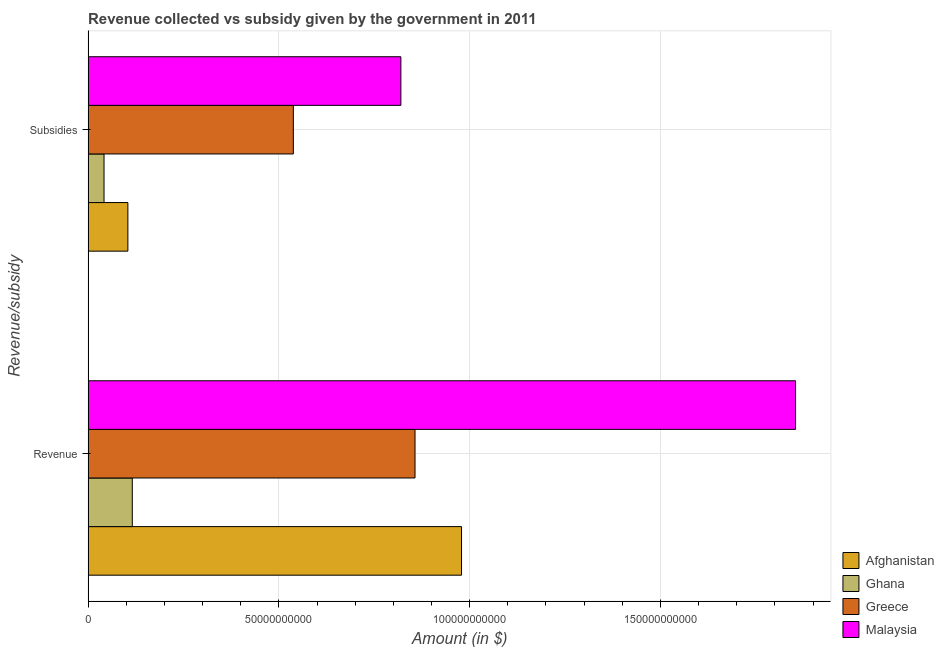Are the number of bars per tick equal to the number of legend labels?
Provide a succinct answer. Yes. What is the label of the 1st group of bars from the top?
Offer a terse response. Subsidies. What is the amount of subsidies given in Ghana?
Ensure brevity in your answer.  4.18e+09. Across all countries, what is the maximum amount of revenue collected?
Provide a short and direct response. 1.85e+11. Across all countries, what is the minimum amount of subsidies given?
Give a very brief answer. 4.18e+09. In which country was the amount of revenue collected maximum?
Offer a terse response. Malaysia. In which country was the amount of revenue collected minimum?
Your response must be concise. Ghana. What is the total amount of subsidies given in the graph?
Make the answer very short. 1.50e+11. What is the difference between the amount of subsidies given in Afghanistan and that in Malaysia?
Your response must be concise. -7.16e+1. What is the difference between the amount of revenue collected in Ghana and the amount of subsidies given in Greece?
Your answer should be compact. -4.22e+1. What is the average amount of subsidies given per country?
Your response must be concise. 3.76e+1. What is the difference between the amount of subsidies given and amount of revenue collected in Greece?
Your answer should be compact. -3.19e+1. In how many countries, is the amount of revenue collected greater than 50000000000 $?
Offer a very short reply. 3. What is the ratio of the amount of revenue collected in Ghana to that in Greece?
Keep it short and to the point. 0.14. In how many countries, is the amount of subsidies given greater than the average amount of subsidies given taken over all countries?
Your response must be concise. 2. What does the 2nd bar from the top in Revenue represents?
Provide a succinct answer. Greece. What does the 2nd bar from the bottom in Subsidies represents?
Ensure brevity in your answer.  Ghana. How many countries are there in the graph?
Provide a short and direct response. 4. What is the difference between two consecutive major ticks on the X-axis?
Your answer should be very brief. 5.00e+1. Are the values on the major ticks of X-axis written in scientific E-notation?
Your response must be concise. No. Does the graph contain any zero values?
Give a very brief answer. No. How many legend labels are there?
Provide a succinct answer. 4. How are the legend labels stacked?
Your response must be concise. Vertical. What is the title of the graph?
Keep it short and to the point. Revenue collected vs subsidy given by the government in 2011. What is the label or title of the X-axis?
Your answer should be compact. Amount (in $). What is the label or title of the Y-axis?
Provide a succinct answer. Revenue/subsidy. What is the Amount (in $) of Afghanistan in Revenue?
Keep it short and to the point. 9.79e+1. What is the Amount (in $) of Ghana in Revenue?
Offer a very short reply. 1.16e+1. What is the Amount (in $) in Greece in Revenue?
Ensure brevity in your answer.  8.57e+1. What is the Amount (in $) in Malaysia in Revenue?
Offer a very short reply. 1.85e+11. What is the Amount (in $) in Afghanistan in Subsidies?
Ensure brevity in your answer.  1.04e+1. What is the Amount (in $) in Ghana in Subsidies?
Keep it short and to the point. 4.18e+09. What is the Amount (in $) in Greece in Subsidies?
Provide a short and direct response. 5.38e+1. What is the Amount (in $) of Malaysia in Subsidies?
Provide a short and direct response. 8.20e+1. Across all Revenue/subsidy, what is the maximum Amount (in $) of Afghanistan?
Your answer should be very brief. 9.79e+1. Across all Revenue/subsidy, what is the maximum Amount (in $) of Ghana?
Your response must be concise. 1.16e+1. Across all Revenue/subsidy, what is the maximum Amount (in $) in Greece?
Your response must be concise. 8.57e+1. Across all Revenue/subsidy, what is the maximum Amount (in $) in Malaysia?
Ensure brevity in your answer.  1.85e+11. Across all Revenue/subsidy, what is the minimum Amount (in $) of Afghanistan?
Keep it short and to the point. 1.04e+1. Across all Revenue/subsidy, what is the minimum Amount (in $) of Ghana?
Offer a very short reply. 4.18e+09. Across all Revenue/subsidy, what is the minimum Amount (in $) of Greece?
Offer a terse response. 5.38e+1. Across all Revenue/subsidy, what is the minimum Amount (in $) in Malaysia?
Your response must be concise. 8.20e+1. What is the total Amount (in $) in Afghanistan in the graph?
Ensure brevity in your answer.  1.08e+11. What is the total Amount (in $) in Ghana in the graph?
Your response must be concise. 1.58e+1. What is the total Amount (in $) in Greece in the graph?
Offer a very short reply. 1.39e+11. What is the total Amount (in $) of Malaysia in the graph?
Your answer should be very brief. 2.67e+11. What is the difference between the Amount (in $) in Afghanistan in Revenue and that in Subsidies?
Offer a very short reply. 8.74e+1. What is the difference between the Amount (in $) in Ghana in Revenue and that in Subsidies?
Your response must be concise. 7.41e+09. What is the difference between the Amount (in $) of Greece in Revenue and that in Subsidies?
Provide a short and direct response. 3.19e+1. What is the difference between the Amount (in $) in Malaysia in Revenue and that in Subsidies?
Your response must be concise. 1.03e+11. What is the difference between the Amount (in $) of Afghanistan in Revenue and the Amount (in $) of Ghana in Subsidies?
Your response must be concise. 9.37e+1. What is the difference between the Amount (in $) in Afghanistan in Revenue and the Amount (in $) in Greece in Subsidies?
Your answer should be very brief. 4.41e+1. What is the difference between the Amount (in $) of Afghanistan in Revenue and the Amount (in $) of Malaysia in Subsidies?
Offer a terse response. 1.59e+1. What is the difference between the Amount (in $) in Ghana in Revenue and the Amount (in $) in Greece in Subsidies?
Give a very brief answer. -4.22e+1. What is the difference between the Amount (in $) in Ghana in Revenue and the Amount (in $) in Malaysia in Subsidies?
Your response must be concise. -7.04e+1. What is the difference between the Amount (in $) in Greece in Revenue and the Amount (in $) in Malaysia in Subsidies?
Provide a short and direct response. 3.71e+09. What is the average Amount (in $) in Afghanistan per Revenue/subsidy?
Your answer should be very brief. 5.42e+1. What is the average Amount (in $) in Ghana per Revenue/subsidy?
Make the answer very short. 7.88e+09. What is the average Amount (in $) of Greece per Revenue/subsidy?
Provide a short and direct response. 6.97e+1. What is the average Amount (in $) of Malaysia per Revenue/subsidy?
Your response must be concise. 1.34e+11. What is the difference between the Amount (in $) of Afghanistan and Amount (in $) of Ghana in Revenue?
Your answer should be very brief. 8.63e+1. What is the difference between the Amount (in $) of Afghanistan and Amount (in $) of Greece in Revenue?
Offer a terse response. 1.22e+1. What is the difference between the Amount (in $) in Afghanistan and Amount (in $) in Malaysia in Revenue?
Your response must be concise. -8.75e+1. What is the difference between the Amount (in $) in Ghana and Amount (in $) in Greece in Revenue?
Your answer should be very brief. -7.41e+1. What is the difference between the Amount (in $) of Ghana and Amount (in $) of Malaysia in Revenue?
Your response must be concise. -1.74e+11. What is the difference between the Amount (in $) in Greece and Amount (in $) in Malaysia in Revenue?
Your response must be concise. -9.97e+1. What is the difference between the Amount (in $) in Afghanistan and Amount (in $) in Ghana in Subsidies?
Give a very brief answer. 6.25e+09. What is the difference between the Amount (in $) in Afghanistan and Amount (in $) in Greece in Subsidies?
Your answer should be very brief. -4.34e+1. What is the difference between the Amount (in $) in Afghanistan and Amount (in $) in Malaysia in Subsidies?
Offer a terse response. -7.16e+1. What is the difference between the Amount (in $) in Ghana and Amount (in $) in Greece in Subsidies?
Provide a short and direct response. -4.96e+1. What is the difference between the Amount (in $) of Ghana and Amount (in $) of Malaysia in Subsidies?
Your answer should be very brief. -7.78e+1. What is the difference between the Amount (in $) in Greece and Amount (in $) in Malaysia in Subsidies?
Keep it short and to the point. -2.82e+1. What is the ratio of the Amount (in $) of Afghanistan in Revenue to that in Subsidies?
Your response must be concise. 9.39. What is the ratio of the Amount (in $) in Ghana in Revenue to that in Subsidies?
Your response must be concise. 2.77. What is the ratio of the Amount (in $) of Greece in Revenue to that in Subsidies?
Your answer should be compact. 1.59. What is the ratio of the Amount (in $) in Malaysia in Revenue to that in Subsidies?
Offer a very short reply. 2.26. What is the difference between the highest and the second highest Amount (in $) in Afghanistan?
Keep it short and to the point. 8.74e+1. What is the difference between the highest and the second highest Amount (in $) of Ghana?
Provide a short and direct response. 7.41e+09. What is the difference between the highest and the second highest Amount (in $) of Greece?
Ensure brevity in your answer.  3.19e+1. What is the difference between the highest and the second highest Amount (in $) in Malaysia?
Make the answer very short. 1.03e+11. What is the difference between the highest and the lowest Amount (in $) in Afghanistan?
Offer a terse response. 8.74e+1. What is the difference between the highest and the lowest Amount (in $) of Ghana?
Your response must be concise. 7.41e+09. What is the difference between the highest and the lowest Amount (in $) of Greece?
Your response must be concise. 3.19e+1. What is the difference between the highest and the lowest Amount (in $) of Malaysia?
Offer a terse response. 1.03e+11. 